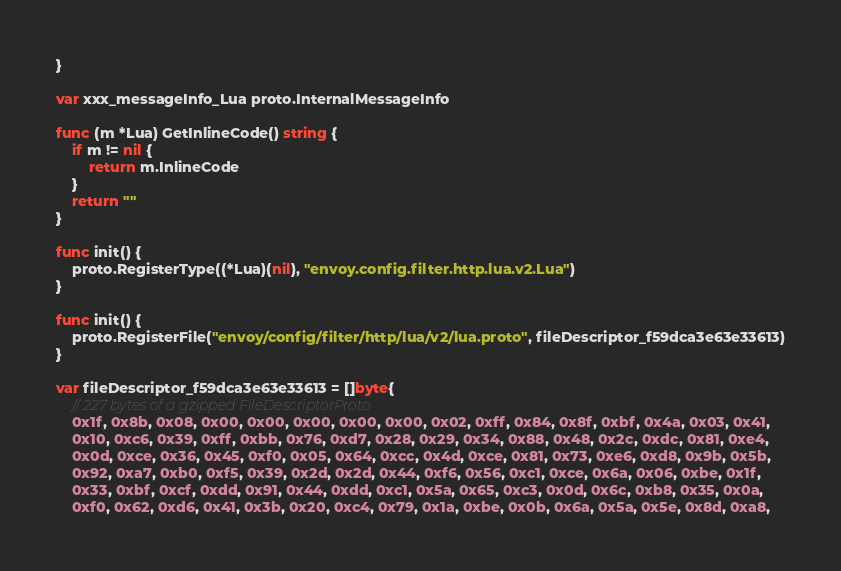Convert code to text. <code><loc_0><loc_0><loc_500><loc_500><_Go_>}

var xxx_messageInfo_Lua proto.InternalMessageInfo

func (m *Lua) GetInlineCode() string {
	if m != nil {
		return m.InlineCode
	}
	return ""
}

func init() {
	proto.RegisterType((*Lua)(nil), "envoy.config.filter.http.lua.v2.Lua")
}

func init() {
	proto.RegisterFile("envoy/config/filter/http/lua/v2/lua.proto", fileDescriptor_f59dca3e63e33613)
}

var fileDescriptor_f59dca3e63e33613 = []byte{
	// 227 bytes of a gzipped FileDescriptorProto
	0x1f, 0x8b, 0x08, 0x00, 0x00, 0x00, 0x00, 0x00, 0x02, 0xff, 0x84, 0x8f, 0xbf, 0x4a, 0x03, 0x41,
	0x10, 0xc6, 0x39, 0xff, 0xbb, 0x76, 0xd7, 0x28, 0x29, 0x34, 0x88, 0x48, 0x2c, 0xdc, 0x81, 0xe4,
	0x0d, 0xce, 0x36, 0x45, 0xf0, 0x05, 0x64, 0xcc, 0x4d, 0xce, 0x81, 0x73, 0xe6, 0xd8, 0x9b, 0x5b,
	0x92, 0xa7, 0xb0, 0xf5, 0x39, 0x2d, 0x2d, 0x44, 0xf6, 0x56, 0xc1, 0xce, 0x6a, 0x06, 0xbe, 0x1f,
	0x33, 0xbf, 0xcf, 0xdd, 0x91, 0x44, 0xdd, 0xc1, 0x5a, 0x65, 0xc3, 0x0d, 0x6c, 0xb8, 0x35, 0x0a,
	0xf0, 0x62, 0xd6, 0x41, 0x3b, 0x20, 0xc4, 0x79, 0x1a, 0xbe, 0x0b, 0x6a, 0x5a, 0x5e, 0x8d, 0xa8,</code> 